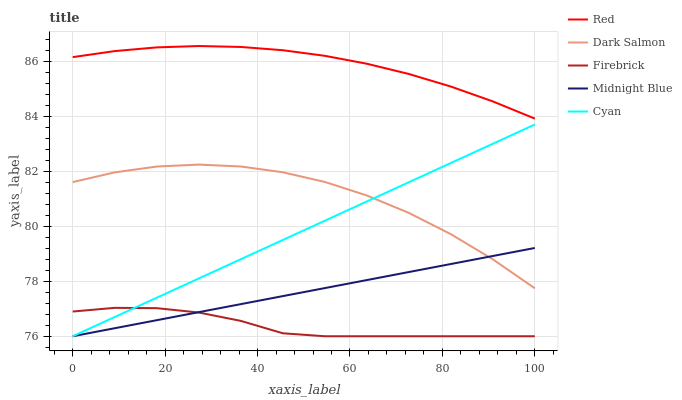Does Firebrick have the minimum area under the curve?
Answer yes or no. Yes. Does Red have the maximum area under the curve?
Answer yes or no. Yes. Does Dark Salmon have the minimum area under the curve?
Answer yes or no. No. Does Dark Salmon have the maximum area under the curve?
Answer yes or no. No. Is Cyan the smoothest?
Answer yes or no. Yes. Is Dark Salmon the roughest?
Answer yes or no. Yes. Is Firebrick the smoothest?
Answer yes or no. No. Is Firebrick the roughest?
Answer yes or no. No. Does Dark Salmon have the lowest value?
Answer yes or no. No. Does Dark Salmon have the highest value?
Answer yes or no. No. Is Firebrick less than Red?
Answer yes or no. Yes. Is Dark Salmon greater than Firebrick?
Answer yes or no. Yes. Does Firebrick intersect Red?
Answer yes or no. No. 